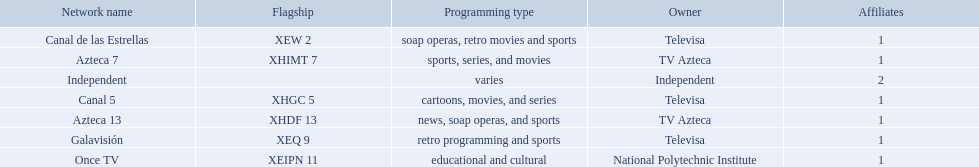Could you parse the entire table? {'header': ['Network name', 'Flagship', 'Programming type', 'Owner', 'Affiliates'], 'rows': [['Canal de las Estrellas', 'XEW 2', 'soap operas, retro movies and sports', 'Televisa', '1'], ['Azteca 7', 'XHIMT 7', 'sports, series, and movies', 'TV Azteca', '1'], ['Independent', '', 'varies', 'Independent', '2'], ['Canal 5', 'XHGC 5', 'cartoons, movies, and series', 'Televisa', '1'], ['Azteca 13', 'XHDF 13', 'news, soap operas, and sports', 'TV Azteca', '1'], ['Galavisión', 'XEQ 9', 'retro programming and sports', 'Televisa', '1'], ['Once TV', 'XEIPN 11', 'educational and cultural', 'National Polytechnic Institute', '1']]} What station shows cartoons? Canal 5. What station shows soap operas? Canal de las Estrellas. What station shows sports? Azteca 7. What stations show sports? Soap operas, retro movies and sports, retro programming and sports, news, soap operas, and sports. What of these is not affiliated with televisa? Azteca 7. 